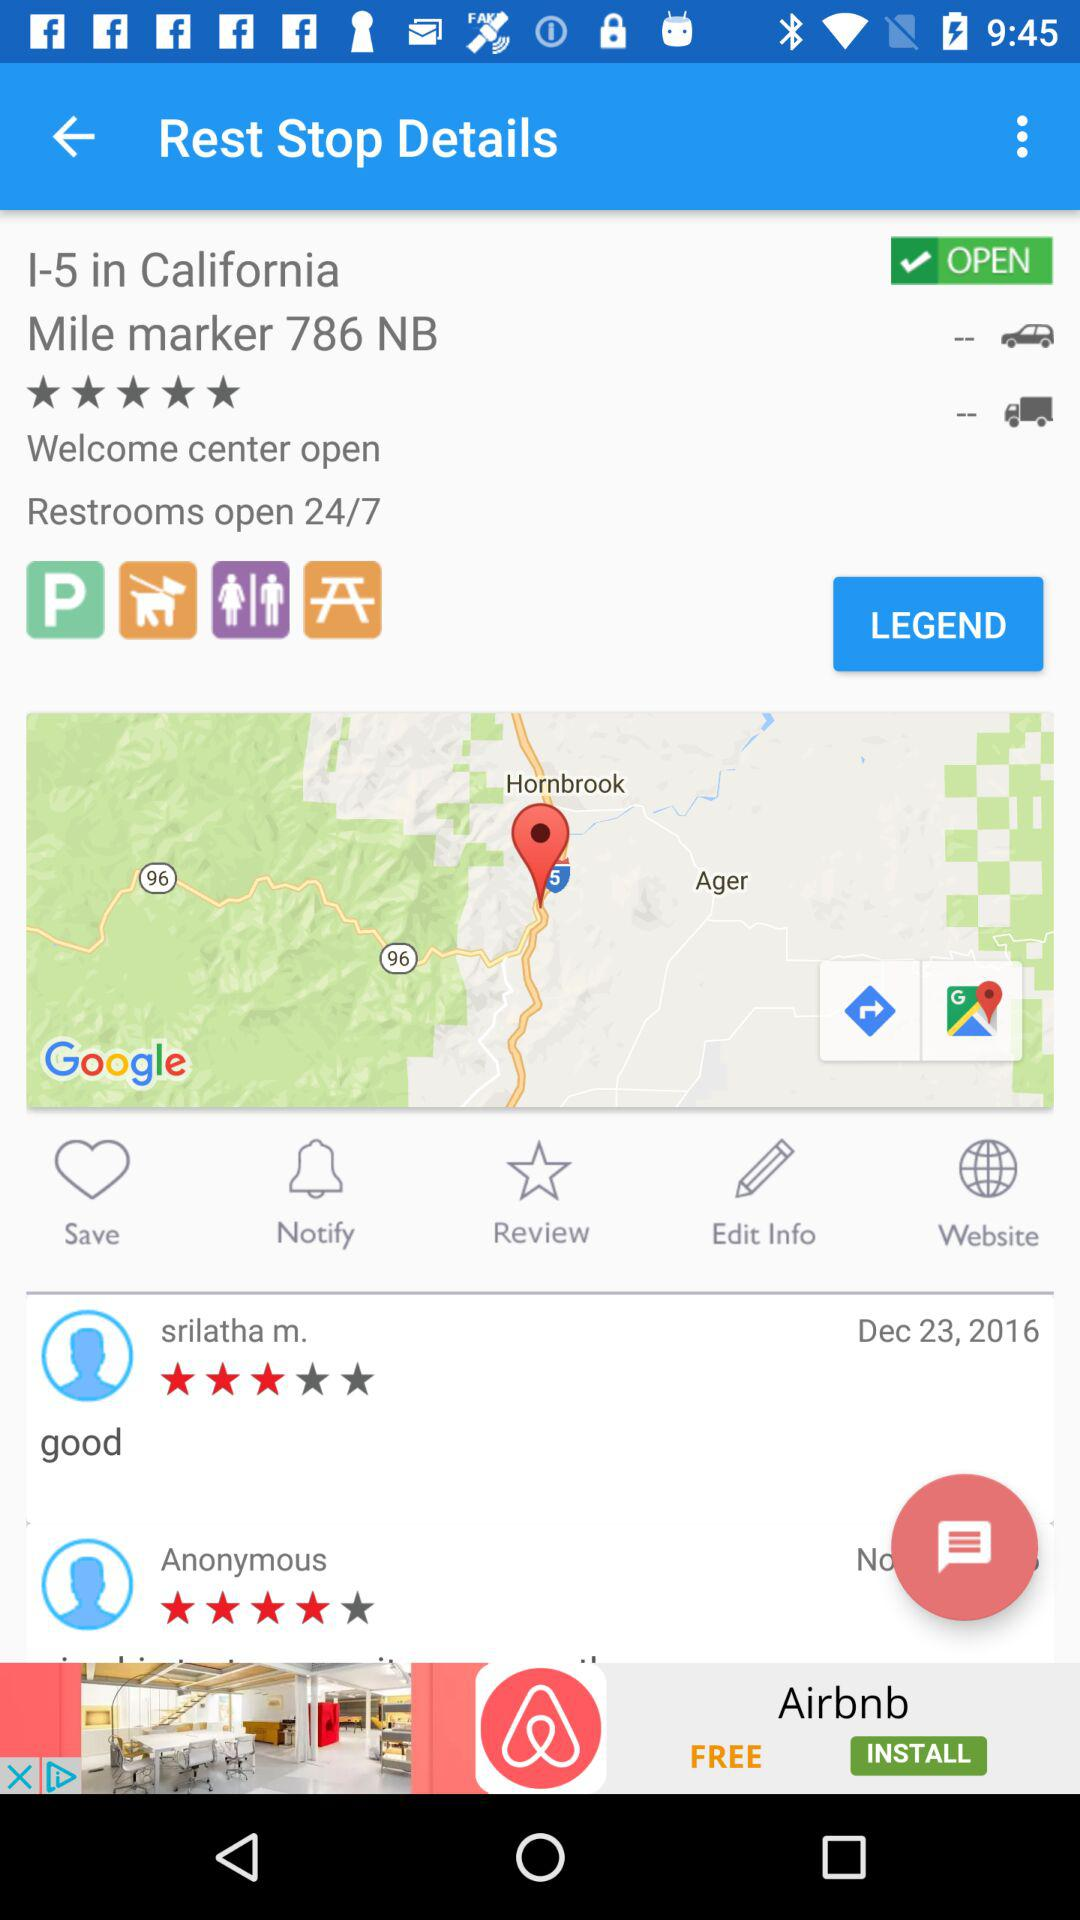What is the location? The location is 1-5 in California, Mile Marker 786 NB. 